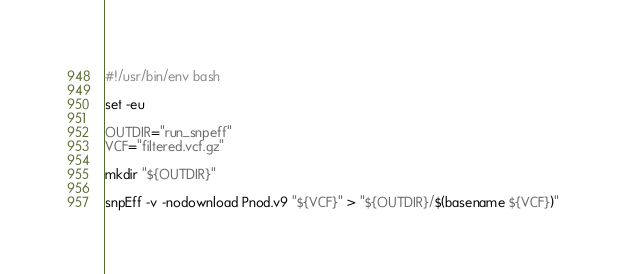<code> <loc_0><loc_0><loc_500><loc_500><_Bash_>#!/usr/bin/env bash

set -eu

OUTDIR="run_snpeff"
VCF="filtered.vcf.gz"

mkdir "${OUTDIR}"

snpEff -v -nodownload Pnod.v9 "${VCF}" > "${OUTDIR}/$(basename ${VCF})"
</code> 